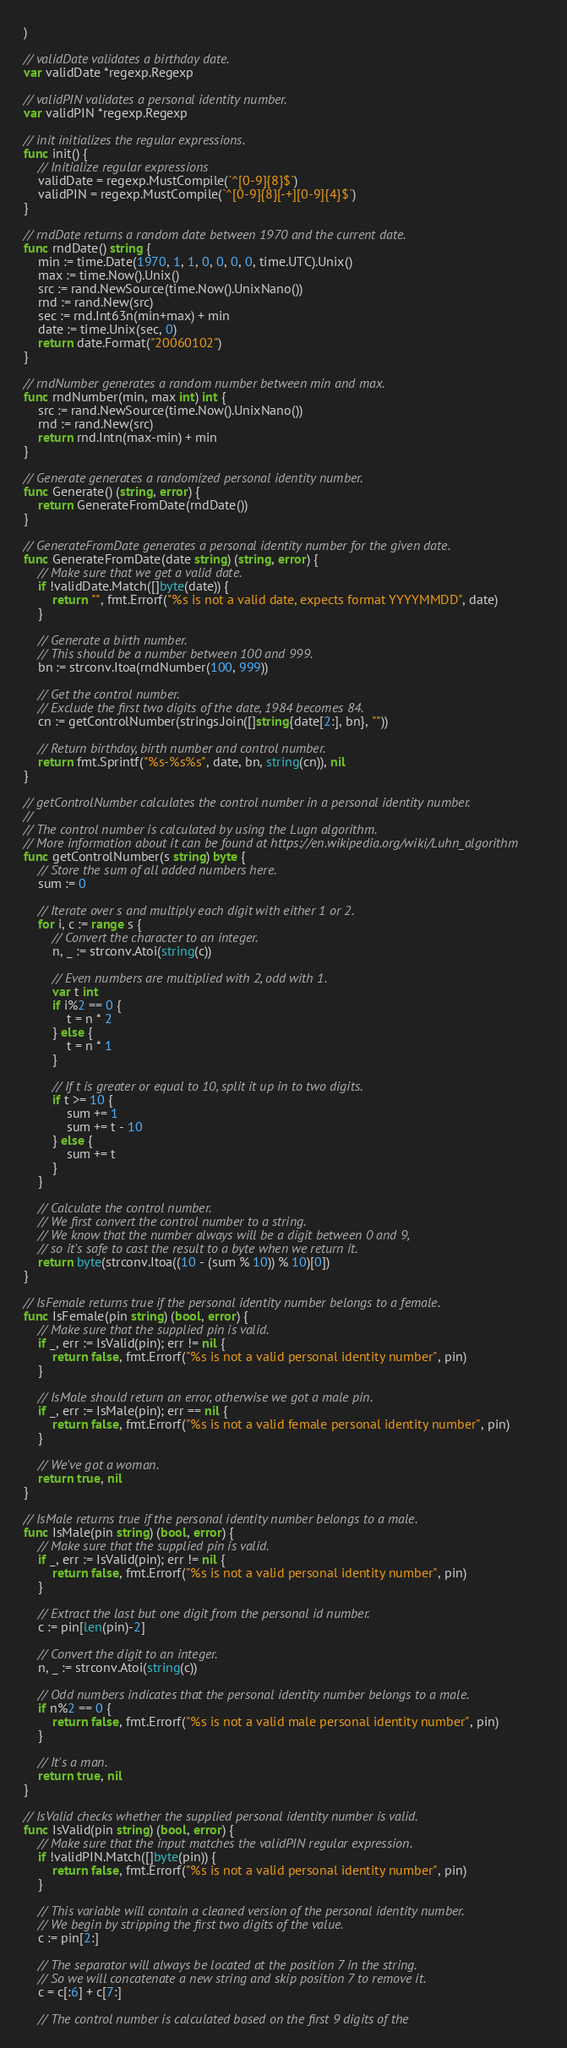<code> <loc_0><loc_0><loc_500><loc_500><_Go_>)

// validDate validates a birthday date.
var validDate *regexp.Regexp

// validPIN validates a personal identity number.
var validPIN *regexp.Regexp

// init initializes the regular expressions.
func init() {
	// Initialize regular expressions
	validDate = regexp.MustCompile(`^[0-9]{8}$`)
	validPIN = regexp.MustCompile(`^[0-9]{8}[-+][0-9]{4}$`)
}

// rndDate returns a random date between 1970 and the current date.
func rndDate() string {
	min := time.Date(1970, 1, 1, 0, 0, 0, 0, time.UTC).Unix()
	max := time.Now().Unix()
	src := rand.NewSource(time.Now().UnixNano())
	rnd := rand.New(src)
	sec := rnd.Int63n(min+max) + min
	date := time.Unix(sec, 0)
	return date.Format("20060102")
}

// rndNumber generates a random number between min and max.
func rndNumber(min, max int) int {
	src := rand.NewSource(time.Now().UnixNano())
	rnd := rand.New(src)
	return rnd.Intn(max-min) + min
}

// Generate generates a randomized personal identity number.
func Generate() (string, error) {
	return GenerateFromDate(rndDate())
}

// GenerateFromDate generates a personal identity number for the given date.
func GenerateFromDate(date string) (string, error) {
	// Make sure that we get a valid date.
	if !validDate.Match([]byte(date)) {
		return "", fmt.Errorf("%s is not a valid date, expects format YYYYMMDD", date)
	}

	// Generate a birth number.
	// This should be a number between 100 and 999.
	bn := strconv.Itoa(rndNumber(100, 999))

	// Get the control number.
	// Exclude the first two digits of the date, 1984 becomes 84.
	cn := getControlNumber(strings.Join([]string{date[2:], bn}, ""))

	// Return birthday, birth number and control number.
	return fmt.Sprintf("%s-%s%s", date, bn, string(cn)), nil
}

// getControlNumber calculates the control number in a personal identity number.
//
// The control number is calculated by using the Lugn algorithm.
// More information about it can be found at https://en.wikipedia.org/wiki/Luhn_algorithm
func getControlNumber(s string) byte {
	// Store the sum of all added numbers here.
	sum := 0

	// Iterate over s and multiply each digit with either 1 or 2.
	for i, c := range s {
		// Convert the character to an integer.
		n, _ := strconv.Atoi(string(c))

		// Even numbers are multiplied with 2, odd with 1.
		var t int
		if i%2 == 0 {
			t = n * 2
		} else {
			t = n * 1
		}

		// If t is greater or equal to 10, split it up in to two digits.
		if t >= 10 {
			sum += 1
			sum += t - 10
		} else {
			sum += t
		}
	}

	// Calculate the control number.
	// We first convert the control number to a string.
	// We know that the number always will be a digit between 0 and 9,
	// so it's safe to cast the result to a byte when we return it.
	return byte(strconv.Itoa((10 - (sum % 10)) % 10)[0])
}

// IsFemale returns true if the personal identity number belongs to a female.
func IsFemale(pin string) (bool, error) {
	// Make sure that the supplied pin is valid.
	if _, err := IsValid(pin); err != nil {
		return false, fmt.Errorf("%s is not a valid personal identity number", pin)
	}

	// IsMale should return an error, otherwise we got a male pin.
	if _, err := IsMale(pin); err == nil {
		return false, fmt.Errorf("%s is not a valid female personal identity number", pin)
	}

	// We've got a woman.
	return true, nil
}

// IsMale returns true if the personal identity number belongs to a male.
func IsMale(pin string) (bool, error) {
	// Make sure that the supplied pin is valid.
	if _, err := IsValid(pin); err != nil {
		return false, fmt.Errorf("%s is not a valid personal identity number", pin)
	}

	// Extract the last but one digit from the personal id number.
	c := pin[len(pin)-2]

	// Convert the digit to an integer.
	n, _ := strconv.Atoi(string(c))

	// Odd numbers indicates that the personal identity number belongs to a male.
	if n%2 == 0 {
		return false, fmt.Errorf("%s is not a valid male personal identity number", pin)
	}

	// It's a man.
	return true, nil
}

// IsValid checks whether the supplied personal identity number is valid.
func IsValid(pin string) (bool, error) {
	// Make sure that the input matches the validPIN regular expression.
	if !validPIN.Match([]byte(pin)) {
		return false, fmt.Errorf("%s is not a valid personal identity number", pin)
	}

	// This variable will contain a cleaned version of the personal identity number.
	// We begin by stripping the first two digits of the value.
	c := pin[2:]

	// The separator will always be located at the position 7 in the string.
	// So we will concatenate a new string and skip position 7 to remove it.
	c = c[:6] + c[7:]

	// The control number is calculated based on the first 9 digits of the</code> 